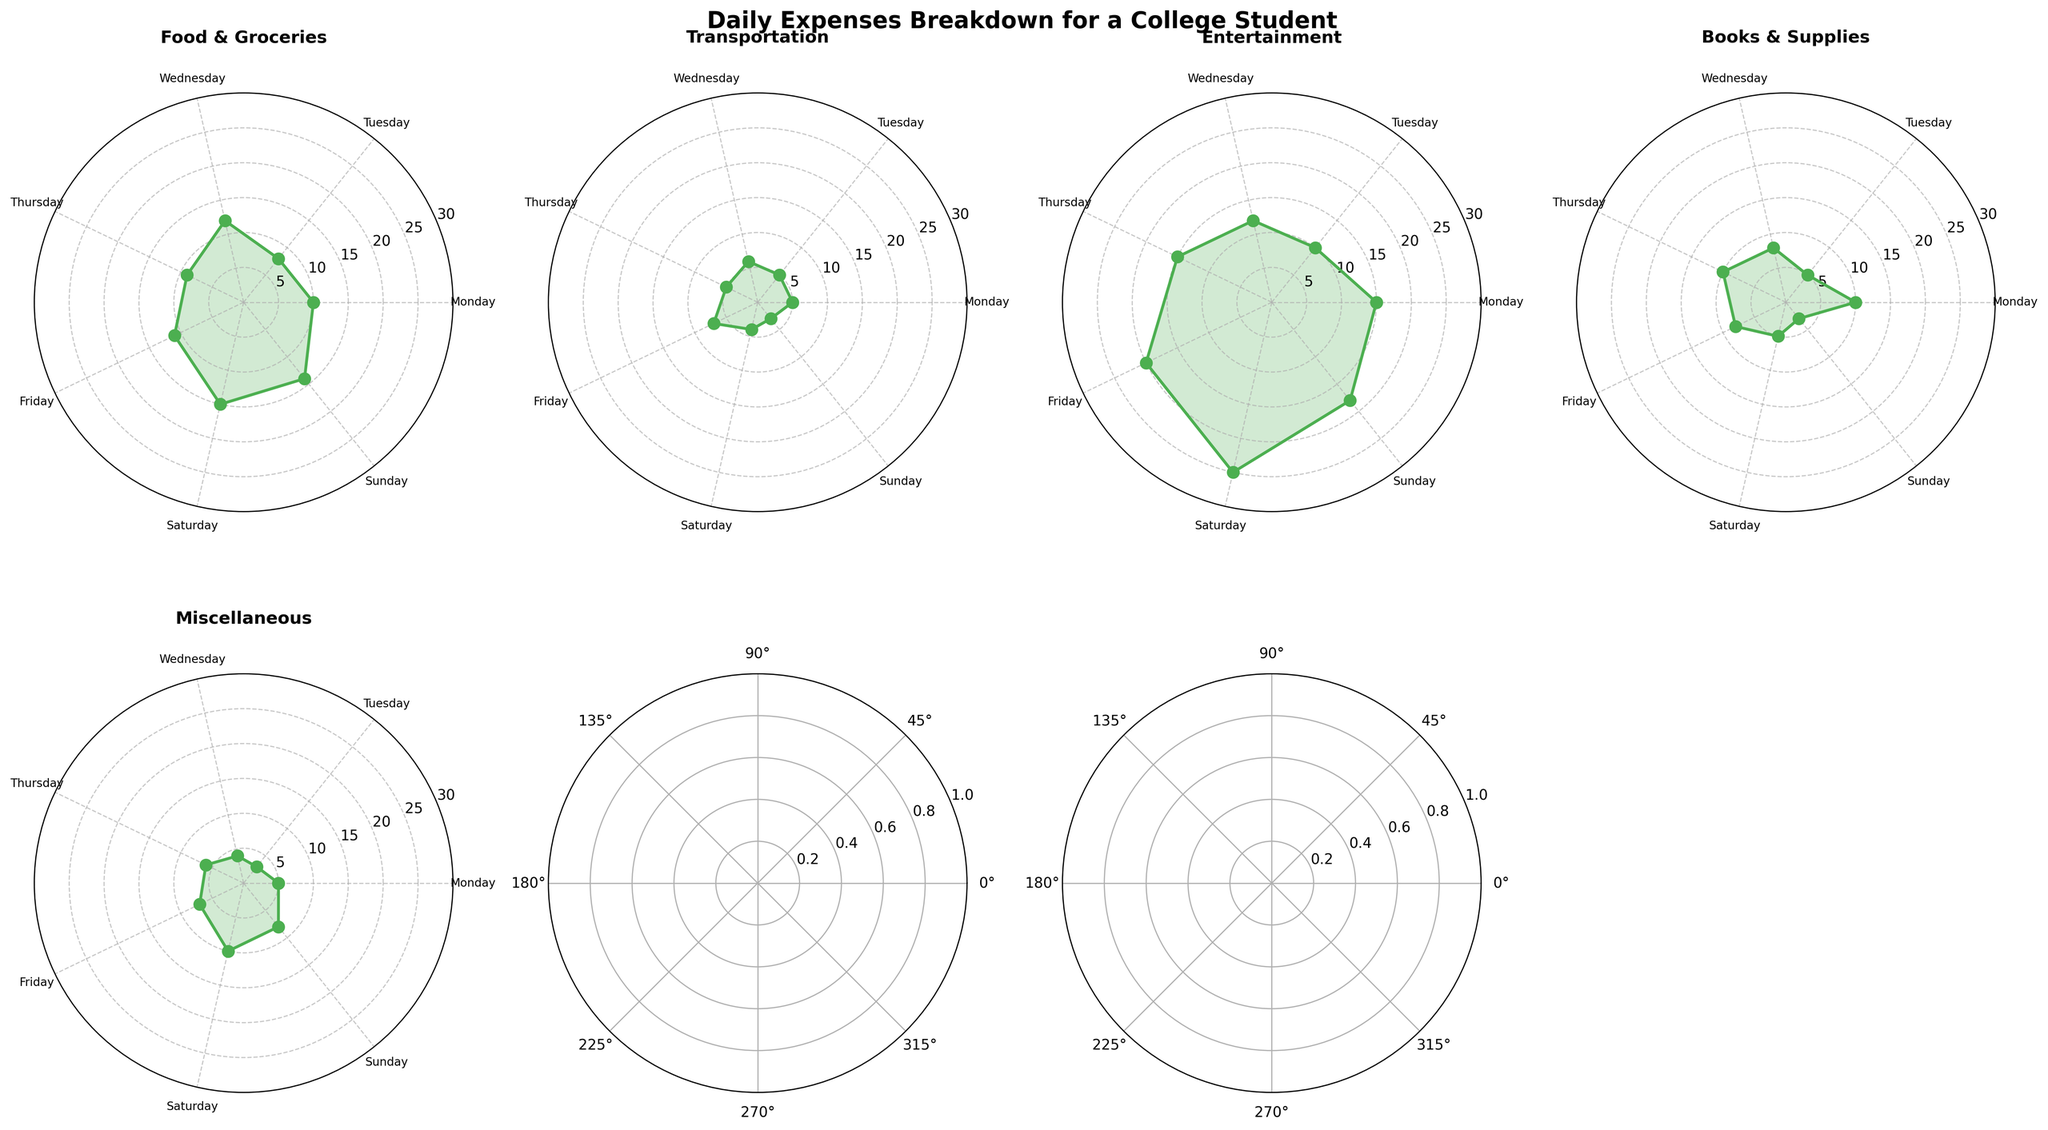Which category has the highest value on Saturday? On the Saturday subplot, observe the values for each category. Entertainment has the highest value, which closes to the outermost edge of the plot, indicating the maximum spending.
Answer: Entertainment What is the total expense for Monday? Sum the values from all categories on the Monday subplot: 10 (Food & Groceries) + 5 (Transportation) + 15 (Entertainment) + 10 (Books & Supplies) + 5 (Miscellaneous) = 45.
Answer: 45 Which day shows the highest spending in the Transportation category? Look at the value for the Transportation category across all subplots. Friday has the highest Transportation spending at a value of 7.
Answer: Friday How does Sunday’s spending on Books & Supplies compare to Friday’s? Compare the value of Books & Supplies on Sunday (3) with that on Friday (8). Sunday’s spending is lower than Friday’s.
Answer: Sunday is lower What is the average spending on Entertainment for the weekdays (Monday to Friday)? Monday (15) + Tuesday (10) + Wednesday (12) + Thursday (15) + Friday (20) = 15+10+12+15+20=72. Divide by 5: 72/5 = 14.4.
Answer: 14.4 Which categories are consistently spending on all seven days? Observe each category across all subplots. All categories (Food & Groceries, Transportation, Entertainment, Books & Supplies, Miscellaneous) are consistently shown.
Answer: All categories Which day has the least overall expenses? Sum the expenses for each day: Monday (45), Tuesday (31), Wednesday (42), Thursday (45), Friday (53), Saturday (59), Sunday (46). The lowest total is Tuesday with 31.
Answer: Tuesday Which category has the lowest average value across all days? Calculate the average for each category: 
Food & Groceries (10+8+12+9+11+15+14)/7 = 79/7 ≈ 11.29
Transportation (5+5+6+5+7+4+3)/7 = 35/7 = 5
Entertainment (15+10+12+15+20+25+18)/7 = 115/7 ≈ 16.43
Books & Supplies (10+5+8+10+8+5+3)/7 = 49/7 ≈ 7
Miscellaneous (5+3+4+6+7+10+8)/7 = 43/7 ≈ 6.14
Transportation has the lowest average.
Answer: Transportation 